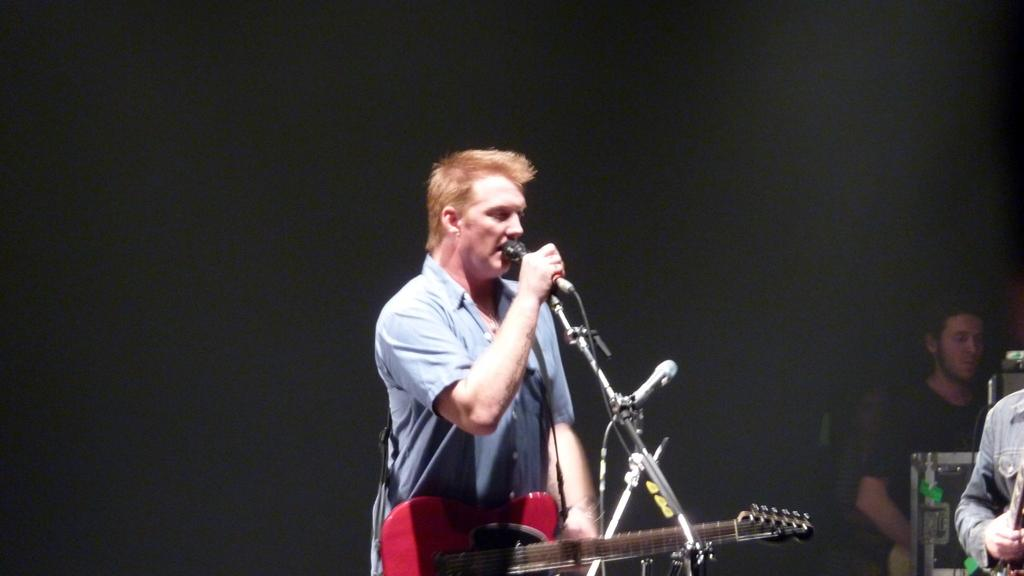What is the man in the image holding? The man is holding a guitar and a microphone in the image. What else can be seen in the image related to the microphone? There is a mic stand in the image. Where is the man holding the mic stand located? The man holding the mic stand is on the right side of the image. What type of oil is being used to lubricate the strings of the guitar in the image? There is no oil present in the image, and the guitar strings do not require lubrication. 